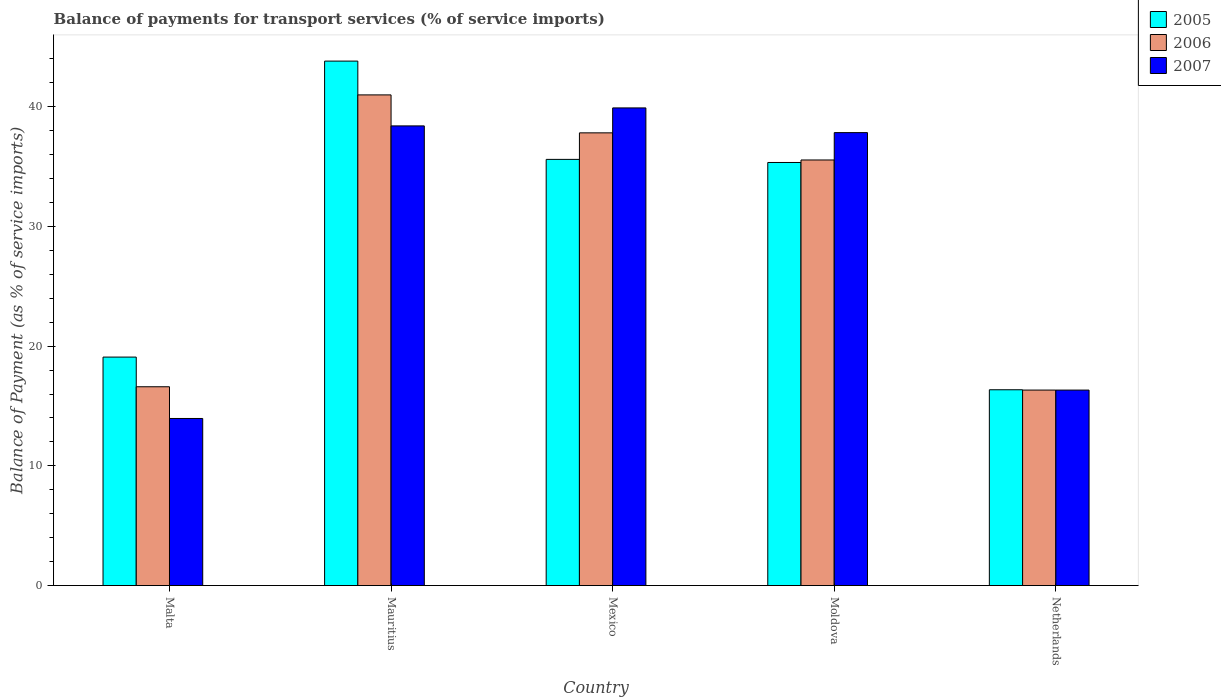How many groups of bars are there?
Your response must be concise. 5. Are the number of bars on each tick of the X-axis equal?
Your answer should be very brief. Yes. What is the label of the 2nd group of bars from the left?
Your answer should be very brief. Mauritius. In how many cases, is the number of bars for a given country not equal to the number of legend labels?
Keep it short and to the point. 0. What is the balance of payments for transport services in 2006 in Moldova?
Give a very brief answer. 35.55. Across all countries, what is the maximum balance of payments for transport services in 2007?
Your answer should be very brief. 39.9. Across all countries, what is the minimum balance of payments for transport services in 2007?
Your answer should be very brief. 13.96. In which country was the balance of payments for transport services in 2007 maximum?
Provide a short and direct response. Mexico. In which country was the balance of payments for transport services in 2007 minimum?
Offer a very short reply. Malta. What is the total balance of payments for transport services in 2007 in the graph?
Make the answer very short. 146.41. What is the difference between the balance of payments for transport services in 2007 in Malta and that in Netherlands?
Your answer should be very brief. -2.37. What is the difference between the balance of payments for transport services in 2007 in Netherlands and the balance of payments for transport services in 2005 in Mauritius?
Make the answer very short. -27.48. What is the average balance of payments for transport services in 2007 per country?
Offer a very short reply. 29.28. What is the difference between the balance of payments for transport services of/in 2006 and balance of payments for transport services of/in 2007 in Malta?
Your answer should be compact. 2.65. What is the ratio of the balance of payments for transport services in 2007 in Mauritius to that in Mexico?
Make the answer very short. 0.96. What is the difference between the highest and the second highest balance of payments for transport services in 2006?
Provide a short and direct response. 5.43. What is the difference between the highest and the lowest balance of payments for transport services in 2005?
Your answer should be compact. 27.45. Is the sum of the balance of payments for transport services in 2006 in Malta and Moldova greater than the maximum balance of payments for transport services in 2007 across all countries?
Make the answer very short. Yes. What does the 2nd bar from the left in Malta represents?
Keep it short and to the point. 2006. What does the 2nd bar from the right in Malta represents?
Give a very brief answer. 2006. Is it the case that in every country, the sum of the balance of payments for transport services in 2007 and balance of payments for transport services in 2006 is greater than the balance of payments for transport services in 2005?
Provide a succinct answer. Yes. Are all the bars in the graph horizontal?
Provide a short and direct response. No. Are the values on the major ticks of Y-axis written in scientific E-notation?
Make the answer very short. No. What is the title of the graph?
Provide a succinct answer. Balance of payments for transport services (% of service imports). What is the label or title of the X-axis?
Your answer should be very brief. Country. What is the label or title of the Y-axis?
Provide a succinct answer. Balance of Payment (as % of service imports). What is the Balance of Payment (as % of service imports) of 2005 in Malta?
Provide a short and direct response. 19.08. What is the Balance of Payment (as % of service imports) in 2006 in Malta?
Provide a succinct answer. 16.61. What is the Balance of Payment (as % of service imports) of 2007 in Malta?
Keep it short and to the point. 13.96. What is the Balance of Payment (as % of service imports) in 2005 in Mauritius?
Ensure brevity in your answer.  43.81. What is the Balance of Payment (as % of service imports) of 2006 in Mauritius?
Provide a short and direct response. 40.98. What is the Balance of Payment (as % of service imports) of 2007 in Mauritius?
Your response must be concise. 38.39. What is the Balance of Payment (as % of service imports) in 2005 in Mexico?
Provide a succinct answer. 35.6. What is the Balance of Payment (as % of service imports) of 2006 in Mexico?
Keep it short and to the point. 37.81. What is the Balance of Payment (as % of service imports) in 2007 in Mexico?
Provide a succinct answer. 39.9. What is the Balance of Payment (as % of service imports) in 2005 in Moldova?
Ensure brevity in your answer.  35.34. What is the Balance of Payment (as % of service imports) in 2006 in Moldova?
Your answer should be compact. 35.55. What is the Balance of Payment (as % of service imports) in 2007 in Moldova?
Provide a short and direct response. 37.83. What is the Balance of Payment (as % of service imports) in 2005 in Netherlands?
Provide a succinct answer. 16.35. What is the Balance of Payment (as % of service imports) in 2006 in Netherlands?
Keep it short and to the point. 16.33. What is the Balance of Payment (as % of service imports) of 2007 in Netherlands?
Your answer should be compact. 16.33. Across all countries, what is the maximum Balance of Payment (as % of service imports) of 2005?
Keep it short and to the point. 43.81. Across all countries, what is the maximum Balance of Payment (as % of service imports) of 2006?
Provide a succinct answer. 40.98. Across all countries, what is the maximum Balance of Payment (as % of service imports) of 2007?
Give a very brief answer. 39.9. Across all countries, what is the minimum Balance of Payment (as % of service imports) in 2005?
Provide a succinct answer. 16.35. Across all countries, what is the minimum Balance of Payment (as % of service imports) in 2006?
Make the answer very short. 16.33. Across all countries, what is the minimum Balance of Payment (as % of service imports) in 2007?
Make the answer very short. 13.96. What is the total Balance of Payment (as % of service imports) of 2005 in the graph?
Provide a short and direct response. 150.18. What is the total Balance of Payment (as % of service imports) in 2006 in the graph?
Provide a short and direct response. 147.28. What is the total Balance of Payment (as % of service imports) in 2007 in the graph?
Make the answer very short. 146.41. What is the difference between the Balance of Payment (as % of service imports) in 2005 in Malta and that in Mauritius?
Give a very brief answer. -24.72. What is the difference between the Balance of Payment (as % of service imports) of 2006 in Malta and that in Mauritius?
Provide a short and direct response. -24.38. What is the difference between the Balance of Payment (as % of service imports) in 2007 in Malta and that in Mauritius?
Offer a very short reply. -24.44. What is the difference between the Balance of Payment (as % of service imports) of 2005 in Malta and that in Mexico?
Your answer should be very brief. -16.51. What is the difference between the Balance of Payment (as % of service imports) of 2006 in Malta and that in Mexico?
Offer a very short reply. -21.21. What is the difference between the Balance of Payment (as % of service imports) of 2007 in Malta and that in Mexico?
Make the answer very short. -25.94. What is the difference between the Balance of Payment (as % of service imports) in 2005 in Malta and that in Moldova?
Give a very brief answer. -16.25. What is the difference between the Balance of Payment (as % of service imports) of 2006 in Malta and that in Moldova?
Your response must be concise. -18.94. What is the difference between the Balance of Payment (as % of service imports) of 2007 in Malta and that in Moldova?
Ensure brevity in your answer.  -23.88. What is the difference between the Balance of Payment (as % of service imports) in 2005 in Malta and that in Netherlands?
Offer a very short reply. 2.73. What is the difference between the Balance of Payment (as % of service imports) of 2006 in Malta and that in Netherlands?
Your answer should be compact. 0.28. What is the difference between the Balance of Payment (as % of service imports) of 2007 in Malta and that in Netherlands?
Provide a short and direct response. -2.37. What is the difference between the Balance of Payment (as % of service imports) in 2005 in Mauritius and that in Mexico?
Your response must be concise. 8.21. What is the difference between the Balance of Payment (as % of service imports) of 2006 in Mauritius and that in Mexico?
Ensure brevity in your answer.  3.17. What is the difference between the Balance of Payment (as % of service imports) in 2007 in Mauritius and that in Mexico?
Offer a terse response. -1.5. What is the difference between the Balance of Payment (as % of service imports) in 2005 in Mauritius and that in Moldova?
Your response must be concise. 8.47. What is the difference between the Balance of Payment (as % of service imports) in 2006 in Mauritius and that in Moldova?
Your answer should be very brief. 5.43. What is the difference between the Balance of Payment (as % of service imports) of 2007 in Mauritius and that in Moldova?
Offer a terse response. 0.56. What is the difference between the Balance of Payment (as % of service imports) in 2005 in Mauritius and that in Netherlands?
Provide a succinct answer. 27.45. What is the difference between the Balance of Payment (as % of service imports) in 2006 in Mauritius and that in Netherlands?
Keep it short and to the point. 24.65. What is the difference between the Balance of Payment (as % of service imports) in 2007 in Mauritius and that in Netherlands?
Your response must be concise. 22.07. What is the difference between the Balance of Payment (as % of service imports) in 2005 in Mexico and that in Moldova?
Your answer should be very brief. 0.26. What is the difference between the Balance of Payment (as % of service imports) of 2006 in Mexico and that in Moldova?
Ensure brevity in your answer.  2.27. What is the difference between the Balance of Payment (as % of service imports) in 2007 in Mexico and that in Moldova?
Ensure brevity in your answer.  2.06. What is the difference between the Balance of Payment (as % of service imports) in 2005 in Mexico and that in Netherlands?
Make the answer very short. 19.24. What is the difference between the Balance of Payment (as % of service imports) of 2006 in Mexico and that in Netherlands?
Your response must be concise. 21.48. What is the difference between the Balance of Payment (as % of service imports) in 2007 in Mexico and that in Netherlands?
Provide a short and direct response. 23.57. What is the difference between the Balance of Payment (as % of service imports) of 2005 in Moldova and that in Netherlands?
Provide a succinct answer. 18.98. What is the difference between the Balance of Payment (as % of service imports) in 2006 in Moldova and that in Netherlands?
Keep it short and to the point. 19.22. What is the difference between the Balance of Payment (as % of service imports) of 2007 in Moldova and that in Netherlands?
Ensure brevity in your answer.  21.51. What is the difference between the Balance of Payment (as % of service imports) of 2005 in Malta and the Balance of Payment (as % of service imports) of 2006 in Mauritius?
Offer a terse response. -21.9. What is the difference between the Balance of Payment (as % of service imports) in 2005 in Malta and the Balance of Payment (as % of service imports) in 2007 in Mauritius?
Make the answer very short. -19.31. What is the difference between the Balance of Payment (as % of service imports) of 2006 in Malta and the Balance of Payment (as % of service imports) of 2007 in Mauritius?
Your answer should be very brief. -21.79. What is the difference between the Balance of Payment (as % of service imports) of 2005 in Malta and the Balance of Payment (as % of service imports) of 2006 in Mexico?
Keep it short and to the point. -18.73. What is the difference between the Balance of Payment (as % of service imports) in 2005 in Malta and the Balance of Payment (as % of service imports) in 2007 in Mexico?
Keep it short and to the point. -20.81. What is the difference between the Balance of Payment (as % of service imports) of 2006 in Malta and the Balance of Payment (as % of service imports) of 2007 in Mexico?
Keep it short and to the point. -23.29. What is the difference between the Balance of Payment (as % of service imports) in 2005 in Malta and the Balance of Payment (as % of service imports) in 2006 in Moldova?
Provide a succinct answer. -16.46. What is the difference between the Balance of Payment (as % of service imports) in 2005 in Malta and the Balance of Payment (as % of service imports) in 2007 in Moldova?
Ensure brevity in your answer.  -18.75. What is the difference between the Balance of Payment (as % of service imports) in 2006 in Malta and the Balance of Payment (as % of service imports) in 2007 in Moldova?
Keep it short and to the point. -21.23. What is the difference between the Balance of Payment (as % of service imports) of 2005 in Malta and the Balance of Payment (as % of service imports) of 2006 in Netherlands?
Make the answer very short. 2.76. What is the difference between the Balance of Payment (as % of service imports) of 2005 in Malta and the Balance of Payment (as % of service imports) of 2007 in Netherlands?
Ensure brevity in your answer.  2.76. What is the difference between the Balance of Payment (as % of service imports) of 2006 in Malta and the Balance of Payment (as % of service imports) of 2007 in Netherlands?
Keep it short and to the point. 0.28. What is the difference between the Balance of Payment (as % of service imports) in 2005 in Mauritius and the Balance of Payment (as % of service imports) in 2006 in Mexico?
Your answer should be very brief. 5.99. What is the difference between the Balance of Payment (as % of service imports) in 2005 in Mauritius and the Balance of Payment (as % of service imports) in 2007 in Mexico?
Ensure brevity in your answer.  3.91. What is the difference between the Balance of Payment (as % of service imports) in 2006 in Mauritius and the Balance of Payment (as % of service imports) in 2007 in Mexico?
Give a very brief answer. 1.09. What is the difference between the Balance of Payment (as % of service imports) in 2005 in Mauritius and the Balance of Payment (as % of service imports) in 2006 in Moldova?
Provide a succinct answer. 8.26. What is the difference between the Balance of Payment (as % of service imports) of 2005 in Mauritius and the Balance of Payment (as % of service imports) of 2007 in Moldova?
Give a very brief answer. 5.97. What is the difference between the Balance of Payment (as % of service imports) of 2006 in Mauritius and the Balance of Payment (as % of service imports) of 2007 in Moldova?
Offer a terse response. 3.15. What is the difference between the Balance of Payment (as % of service imports) of 2005 in Mauritius and the Balance of Payment (as % of service imports) of 2006 in Netherlands?
Your answer should be compact. 27.48. What is the difference between the Balance of Payment (as % of service imports) in 2005 in Mauritius and the Balance of Payment (as % of service imports) in 2007 in Netherlands?
Your response must be concise. 27.48. What is the difference between the Balance of Payment (as % of service imports) of 2006 in Mauritius and the Balance of Payment (as % of service imports) of 2007 in Netherlands?
Your answer should be compact. 24.65. What is the difference between the Balance of Payment (as % of service imports) in 2005 in Mexico and the Balance of Payment (as % of service imports) in 2006 in Moldova?
Make the answer very short. 0.05. What is the difference between the Balance of Payment (as % of service imports) in 2005 in Mexico and the Balance of Payment (as % of service imports) in 2007 in Moldova?
Make the answer very short. -2.24. What is the difference between the Balance of Payment (as % of service imports) in 2006 in Mexico and the Balance of Payment (as % of service imports) in 2007 in Moldova?
Provide a succinct answer. -0.02. What is the difference between the Balance of Payment (as % of service imports) of 2005 in Mexico and the Balance of Payment (as % of service imports) of 2006 in Netherlands?
Offer a terse response. 19.27. What is the difference between the Balance of Payment (as % of service imports) in 2005 in Mexico and the Balance of Payment (as % of service imports) in 2007 in Netherlands?
Your response must be concise. 19.27. What is the difference between the Balance of Payment (as % of service imports) in 2006 in Mexico and the Balance of Payment (as % of service imports) in 2007 in Netherlands?
Provide a succinct answer. 21.49. What is the difference between the Balance of Payment (as % of service imports) in 2005 in Moldova and the Balance of Payment (as % of service imports) in 2006 in Netherlands?
Ensure brevity in your answer.  19.01. What is the difference between the Balance of Payment (as % of service imports) of 2005 in Moldova and the Balance of Payment (as % of service imports) of 2007 in Netherlands?
Give a very brief answer. 19.01. What is the difference between the Balance of Payment (as % of service imports) of 2006 in Moldova and the Balance of Payment (as % of service imports) of 2007 in Netherlands?
Your answer should be very brief. 19.22. What is the average Balance of Payment (as % of service imports) in 2005 per country?
Make the answer very short. 30.04. What is the average Balance of Payment (as % of service imports) in 2006 per country?
Provide a short and direct response. 29.46. What is the average Balance of Payment (as % of service imports) in 2007 per country?
Keep it short and to the point. 29.28. What is the difference between the Balance of Payment (as % of service imports) of 2005 and Balance of Payment (as % of service imports) of 2006 in Malta?
Provide a short and direct response. 2.48. What is the difference between the Balance of Payment (as % of service imports) of 2005 and Balance of Payment (as % of service imports) of 2007 in Malta?
Your answer should be very brief. 5.13. What is the difference between the Balance of Payment (as % of service imports) of 2006 and Balance of Payment (as % of service imports) of 2007 in Malta?
Your answer should be compact. 2.65. What is the difference between the Balance of Payment (as % of service imports) of 2005 and Balance of Payment (as % of service imports) of 2006 in Mauritius?
Your answer should be compact. 2.82. What is the difference between the Balance of Payment (as % of service imports) in 2005 and Balance of Payment (as % of service imports) in 2007 in Mauritius?
Offer a very short reply. 5.41. What is the difference between the Balance of Payment (as % of service imports) of 2006 and Balance of Payment (as % of service imports) of 2007 in Mauritius?
Ensure brevity in your answer.  2.59. What is the difference between the Balance of Payment (as % of service imports) in 2005 and Balance of Payment (as % of service imports) in 2006 in Mexico?
Make the answer very short. -2.22. What is the difference between the Balance of Payment (as % of service imports) of 2005 and Balance of Payment (as % of service imports) of 2007 in Mexico?
Your response must be concise. -4.3. What is the difference between the Balance of Payment (as % of service imports) in 2006 and Balance of Payment (as % of service imports) in 2007 in Mexico?
Your answer should be compact. -2.08. What is the difference between the Balance of Payment (as % of service imports) of 2005 and Balance of Payment (as % of service imports) of 2006 in Moldova?
Keep it short and to the point. -0.21. What is the difference between the Balance of Payment (as % of service imports) in 2005 and Balance of Payment (as % of service imports) in 2007 in Moldova?
Make the answer very short. -2.49. What is the difference between the Balance of Payment (as % of service imports) of 2006 and Balance of Payment (as % of service imports) of 2007 in Moldova?
Your response must be concise. -2.29. What is the difference between the Balance of Payment (as % of service imports) of 2005 and Balance of Payment (as % of service imports) of 2006 in Netherlands?
Your answer should be compact. 0.03. What is the difference between the Balance of Payment (as % of service imports) of 2005 and Balance of Payment (as % of service imports) of 2007 in Netherlands?
Your response must be concise. 0.03. What is the difference between the Balance of Payment (as % of service imports) of 2006 and Balance of Payment (as % of service imports) of 2007 in Netherlands?
Make the answer very short. 0. What is the ratio of the Balance of Payment (as % of service imports) in 2005 in Malta to that in Mauritius?
Offer a very short reply. 0.44. What is the ratio of the Balance of Payment (as % of service imports) in 2006 in Malta to that in Mauritius?
Your response must be concise. 0.41. What is the ratio of the Balance of Payment (as % of service imports) in 2007 in Malta to that in Mauritius?
Your response must be concise. 0.36. What is the ratio of the Balance of Payment (as % of service imports) in 2005 in Malta to that in Mexico?
Offer a very short reply. 0.54. What is the ratio of the Balance of Payment (as % of service imports) of 2006 in Malta to that in Mexico?
Offer a terse response. 0.44. What is the ratio of the Balance of Payment (as % of service imports) of 2007 in Malta to that in Mexico?
Provide a succinct answer. 0.35. What is the ratio of the Balance of Payment (as % of service imports) of 2005 in Malta to that in Moldova?
Your answer should be very brief. 0.54. What is the ratio of the Balance of Payment (as % of service imports) of 2006 in Malta to that in Moldova?
Offer a terse response. 0.47. What is the ratio of the Balance of Payment (as % of service imports) in 2007 in Malta to that in Moldova?
Provide a short and direct response. 0.37. What is the ratio of the Balance of Payment (as % of service imports) in 2005 in Malta to that in Netherlands?
Ensure brevity in your answer.  1.17. What is the ratio of the Balance of Payment (as % of service imports) of 2006 in Malta to that in Netherlands?
Provide a succinct answer. 1.02. What is the ratio of the Balance of Payment (as % of service imports) of 2007 in Malta to that in Netherlands?
Your answer should be compact. 0.85. What is the ratio of the Balance of Payment (as % of service imports) in 2005 in Mauritius to that in Mexico?
Your answer should be very brief. 1.23. What is the ratio of the Balance of Payment (as % of service imports) of 2006 in Mauritius to that in Mexico?
Your response must be concise. 1.08. What is the ratio of the Balance of Payment (as % of service imports) in 2007 in Mauritius to that in Mexico?
Your answer should be very brief. 0.96. What is the ratio of the Balance of Payment (as % of service imports) in 2005 in Mauritius to that in Moldova?
Ensure brevity in your answer.  1.24. What is the ratio of the Balance of Payment (as % of service imports) of 2006 in Mauritius to that in Moldova?
Provide a succinct answer. 1.15. What is the ratio of the Balance of Payment (as % of service imports) of 2007 in Mauritius to that in Moldova?
Offer a very short reply. 1.01. What is the ratio of the Balance of Payment (as % of service imports) of 2005 in Mauritius to that in Netherlands?
Give a very brief answer. 2.68. What is the ratio of the Balance of Payment (as % of service imports) of 2006 in Mauritius to that in Netherlands?
Provide a short and direct response. 2.51. What is the ratio of the Balance of Payment (as % of service imports) in 2007 in Mauritius to that in Netherlands?
Your answer should be compact. 2.35. What is the ratio of the Balance of Payment (as % of service imports) of 2005 in Mexico to that in Moldova?
Provide a succinct answer. 1.01. What is the ratio of the Balance of Payment (as % of service imports) of 2006 in Mexico to that in Moldova?
Make the answer very short. 1.06. What is the ratio of the Balance of Payment (as % of service imports) of 2007 in Mexico to that in Moldova?
Offer a very short reply. 1.05. What is the ratio of the Balance of Payment (as % of service imports) of 2005 in Mexico to that in Netherlands?
Ensure brevity in your answer.  2.18. What is the ratio of the Balance of Payment (as % of service imports) in 2006 in Mexico to that in Netherlands?
Keep it short and to the point. 2.32. What is the ratio of the Balance of Payment (as % of service imports) in 2007 in Mexico to that in Netherlands?
Provide a succinct answer. 2.44. What is the ratio of the Balance of Payment (as % of service imports) of 2005 in Moldova to that in Netherlands?
Make the answer very short. 2.16. What is the ratio of the Balance of Payment (as % of service imports) of 2006 in Moldova to that in Netherlands?
Offer a very short reply. 2.18. What is the ratio of the Balance of Payment (as % of service imports) in 2007 in Moldova to that in Netherlands?
Make the answer very short. 2.32. What is the difference between the highest and the second highest Balance of Payment (as % of service imports) in 2005?
Give a very brief answer. 8.21. What is the difference between the highest and the second highest Balance of Payment (as % of service imports) of 2006?
Ensure brevity in your answer.  3.17. What is the difference between the highest and the second highest Balance of Payment (as % of service imports) of 2007?
Ensure brevity in your answer.  1.5. What is the difference between the highest and the lowest Balance of Payment (as % of service imports) in 2005?
Offer a very short reply. 27.45. What is the difference between the highest and the lowest Balance of Payment (as % of service imports) of 2006?
Your response must be concise. 24.65. What is the difference between the highest and the lowest Balance of Payment (as % of service imports) of 2007?
Ensure brevity in your answer.  25.94. 